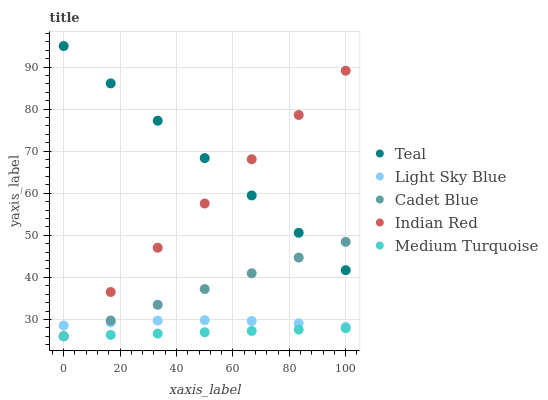Does Medium Turquoise have the minimum area under the curve?
Answer yes or no. Yes. Does Teal have the maximum area under the curve?
Answer yes or no. Yes. Does Light Sky Blue have the minimum area under the curve?
Answer yes or no. No. Does Light Sky Blue have the maximum area under the curve?
Answer yes or no. No. Is Medium Turquoise the smoothest?
Answer yes or no. Yes. Is Light Sky Blue the roughest?
Answer yes or no. Yes. Is Light Sky Blue the smoothest?
Answer yes or no. No. Is Medium Turquoise the roughest?
Answer yes or no. No. Does Cadet Blue have the lowest value?
Answer yes or no. Yes. Does Light Sky Blue have the lowest value?
Answer yes or no. No. Does Teal have the highest value?
Answer yes or no. Yes. Does Light Sky Blue have the highest value?
Answer yes or no. No. Is Light Sky Blue less than Teal?
Answer yes or no. Yes. Is Teal greater than Light Sky Blue?
Answer yes or no. Yes. Does Medium Turquoise intersect Cadet Blue?
Answer yes or no. Yes. Is Medium Turquoise less than Cadet Blue?
Answer yes or no. No. Is Medium Turquoise greater than Cadet Blue?
Answer yes or no. No. Does Light Sky Blue intersect Teal?
Answer yes or no. No. 